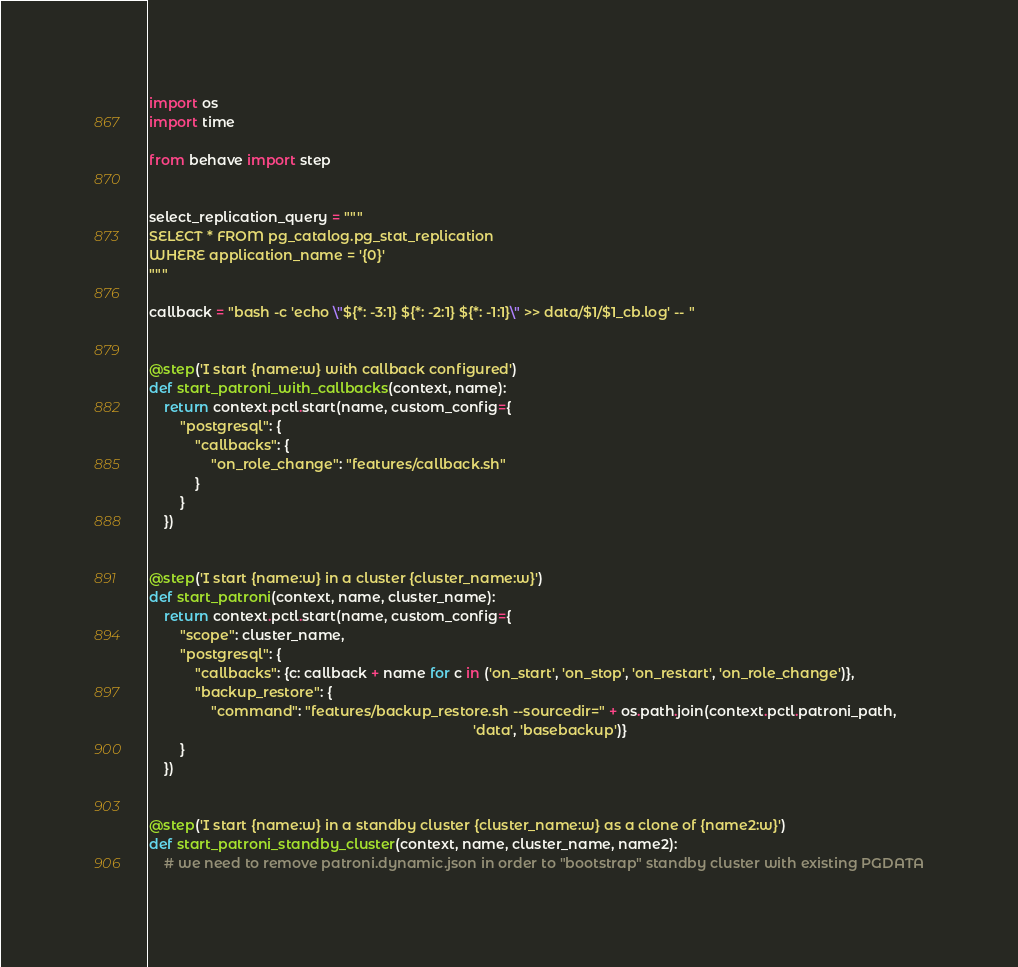<code> <loc_0><loc_0><loc_500><loc_500><_Python_>import os
import time

from behave import step


select_replication_query = """
SELECT * FROM pg_catalog.pg_stat_replication
WHERE application_name = '{0}'
"""

callback = "bash -c 'echo \"${*: -3:1} ${*: -2:1} ${*: -1:1}\" >> data/$1/$1_cb.log' -- "


@step('I start {name:w} with callback configured')
def start_patroni_with_callbacks(context, name):
    return context.pctl.start(name, custom_config={
        "postgresql": {
            "callbacks": {
                "on_role_change": "features/callback.sh"
            }
        }
    })


@step('I start {name:w} in a cluster {cluster_name:w}')
def start_patroni(context, name, cluster_name):
    return context.pctl.start(name, custom_config={
        "scope": cluster_name,
        "postgresql": {
            "callbacks": {c: callback + name for c in ('on_start', 'on_stop', 'on_restart', 'on_role_change')},
            "backup_restore": {
                "command": "features/backup_restore.sh --sourcedir=" + os.path.join(context.pctl.patroni_path,
                                                                                    'data', 'basebackup')}
        }
    })


@step('I start {name:w} in a standby cluster {cluster_name:w} as a clone of {name2:w}')
def start_patroni_standby_cluster(context, name, cluster_name, name2):
    # we need to remove patroni.dynamic.json in order to "bootstrap" standby cluster with existing PGDATA</code> 